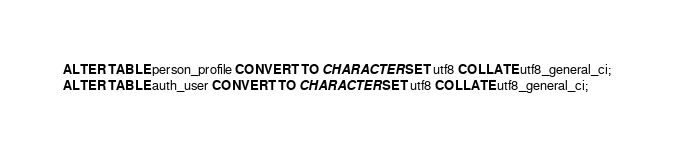<code> <loc_0><loc_0><loc_500><loc_500><_SQL_>ALTER TABLE person_profile CONVERT TO CHARACTER SET utf8 COLLATE utf8_general_ci;
ALTER TABLE auth_user CONVERT TO CHARACTER SET utf8 COLLATE utf8_general_ci;</code> 